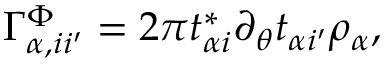Convert formula to latex. <formula><loc_0><loc_0><loc_500><loc_500>\Gamma _ { \alpha , i i ^ { \prime } } ^ { \Phi } = 2 \pi t _ { \alpha i } ^ { * } \partial _ { \theta } t _ { \alpha i ^ { \prime } } \rho _ { \alpha } ,</formula> 